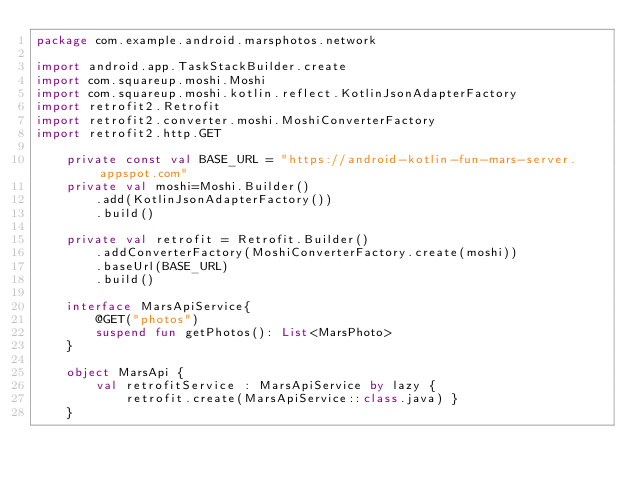<code> <loc_0><loc_0><loc_500><loc_500><_Kotlin_>package com.example.android.marsphotos.network

import android.app.TaskStackBuilder.create
import com.squareup.moshi.Moshi
import com.squareup.moshi.kotlin.reflect.KotlinJsonAdapterFactory
import retrofit2.Retrofit
import retrofit2.converter.moshi.MoshiConverterFactory
import retrofit2.http.GET

    private const val BASE_URL = "https://android-kotlin-fun-mars-server.appspot.com"
    private val moshi=Moshi.Builder()
        .add(KotlinJsonAdapterFactory())
        .build()

    private val retrofit = Retrofit.Builder()
        .addConverterFactory(MoshiConverterFactory.create(moshi))
        .baseUrl(BASE_URL)
        .build()

    interface MarsApiService{
        @GET("photos")
        suspend fun getPhotos(): List<MarsPhoto>
    }

    object MarsApi {
        val retrofitService : MarsApiService by lazy {
            retrofit.create(MarsApiService::class.java) }
    }</code> 